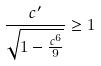Convert formula to latex. <formula><loc_0><loc_0><loc_500><loc_500>\frac { c ^ { \prime } } { \sqrt { 1 - \frac { c ^ { 6 } } { 9 } } } \geq 1</formula> 